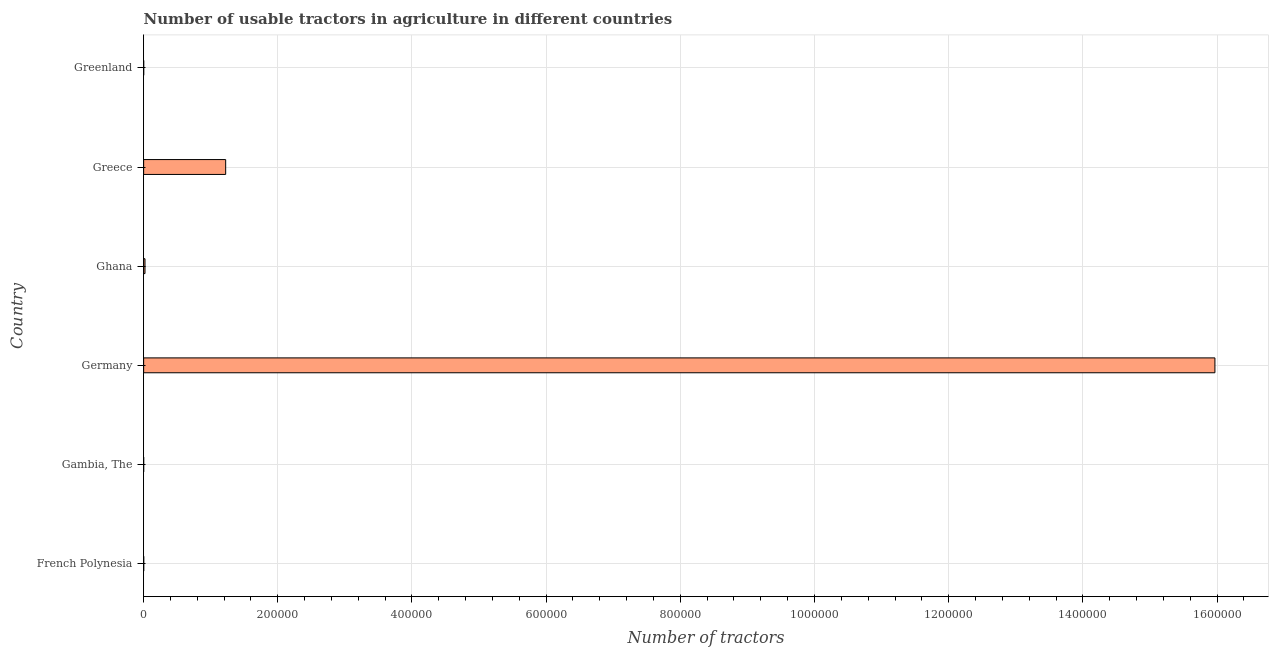What is the title of the graph?
Offer a terse response. Number of usable tractors in agriculture in different countries. What is the label or title of the X-axis?
Provide a short and direct response. Number of tractors. What is the label or title of the Y-axis?
Give a very brief answer. Country. What is the number of tractors in Germany?
Offer a very short reply. 1.60e+06. Across all countries, what is the maximum number of tractors?
Offer a very short reply. 1.60e+06. In which country was the number of tractors minimum?
Your response must be concise. Gambia, The. What is the sum of the number of tractors?
Keep it short and to the point. 1.72e+06. What is the difference between the number of tractors in Germany and Greenland?
Provide a succinct answer. 1.60e+06. What is the average number of tractors per country?
Ensure brevity in your answer.  2.87e+05. What is the median number of tractors?
Offer a very short reply. 1080. What is the ratio of the number of tractors in Germany to that in Greece?
Your answer should be very brief. 13.06. Is the number of tractors in Gambia, The less than that in Greenland?
Your response must be concise. Yes. What is the difference between the highest and the second highest number of tractors?
Your answer should be compact. 1.47e+06. What is the difference between the highest and the lowest number of tractors?
Provide a succinct answer. 1.60e+06. In how many countries, is the number of tractors greater than the average number of tractors taken over all countries?
Offer a terse response. 1. How many countries are there in the graph?
Ensure brevity in your answer.  6. What is the difference between two consecutive major ticks on the X-axis?
Keep it short and to the point. 2.00e+05. What is the Number of tractors in French Polynesia?
Give a very brief answer. 140. What is the Number of tractors in Germany?
Offer a very short reply. 1.60e+06. What is the Number of tractors in Ghana?
Offer a terse response. 2020. What is the Number of tractors in Greece?
Provide a succinct answer. 1.22e+05. What is the Number of tractors in Greenland?
Provide a succinct answer. 72. What is the difference between the Number of tractors in French Polynesia and Gambia, The?
Your answer should be compact. 94. What is the difference between the Number of tractors in French Polynesia and Germany?
Provide a succinct answer. -1.60e+06. What is the difference between the Number of tractors in French Polynesia and Ghana?
Ensure brevity in your answer.  -1880. What is the difference between the Number of tractors in French Polynesia and Greece?
Give a very brief answer. -1.22e+05. What is the difference between the Number of tractors in Gambia, The and Germany?
Your response must be concise. -1.60e+06. What is the difference between the Number of tractors in Gambia, The and Ghana?
Your answer should be compact. -1974. What is the difference between the Number of tractors in Gambia, The and Greece?
Ensure brevity in your answer.  -1.22e+05. What is the difference between the Number of tractors in Germany and Ghana?
Make the answer very short. 1.59e+06. What is the difference between the Number of tractors in Germany and Greece?
Offer a very short reply. 1.47e+06. What is the difference between the Number of tractors in Germany and Greenland?
Offer a very short reply. 1.60e+06. What is the difference between the Number of tractors in Ghana and Greece?
Provide a succinct answer. -1.20e+05. What is the difference between the Number of tractors in Ghana and Greenland?
Ensure brevity in your answer.  1948. What is the difference between the Number of tractors in Greece and Greenland?
Provide a short and direct response. 1.22e+05. What is the ratio of the Number of tractors in French Polynesia to that in Gambia, The?
Your answer should be compact. 3.04. What is the ratio of the Number of tractors in French Polynesia to that in Ghana?
Ensure brevity in your answer.  0.07. What is the ratio of the Number of tractors in French Polynesia to that in Greenland?
Make the answer very short. 1.94. What is the ratio of the Number of tractors in Gambia, The to that in Ghana?
Keep it short and to the point. 0.02. What is the ratio of the Number of tractors in Gambia, The to that in Greenland?
Your answer should be very brief. 0.64. What is the ratio of the Number of tractors in Germany to that in Ghana?
Offer a terse response. 790.55. What is the ratio of the Number of tractors in Germany to that in Greece?
Ensure brevity in your answer.  13.06. What is the ratio of the Number of tractors in Germany to that in Greenland?
Your answer should be compact. 2.22e+04. What is the ratio of the Number of tractors in Ghana to that in Greece?
Make the answer very short. 0.02. What is the ratio of the Number of tractors in Ghana to that in Greenland?
Provide a succinct answer. 28.06. What is the ratio of the Number of tractors in Greece to that in Greenland?
Keep it short and to the point. 1698.17. 